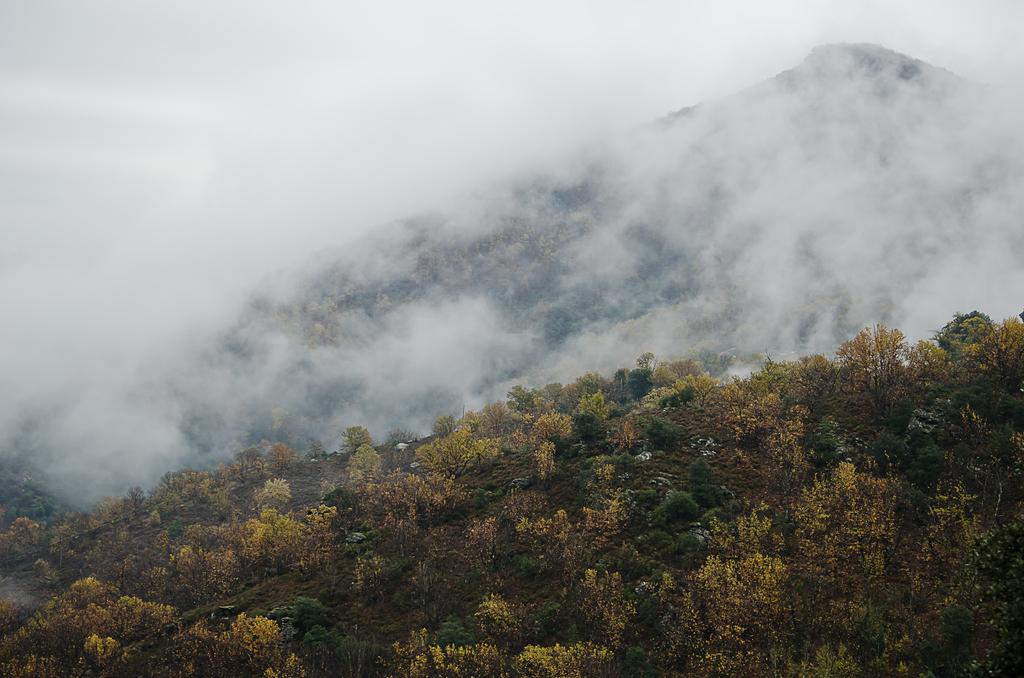What type of vegetation is present at the bottom of the image? There are trees at the bottom of the image. What geographical features can be seen in the background of the image? Hills are visible in the background of the image. How is the visibility of the hills affected in the image? The hills are covered with fog. Can you see a seashore in the image? There is no seashore present in the image; it features trees and hills covered with fog. Is there an airplane flying over the hills in the image? There is no airplane visible in the image; it only shows trees and hills covered with fog. 